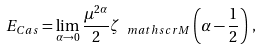Convert formula to latex. <formula><loc_0><loc_0><loc_500><loc_500>E _ { C a s } = \lim _ { \alpha \to 0 } \frac { \mu ^ { 2 \alpha } } { 2 } \zeta _ { \ m a t h s c r { M } } \left ( \alpha - \frac { 1 } { 2 } \right ) \, ,</formula> 